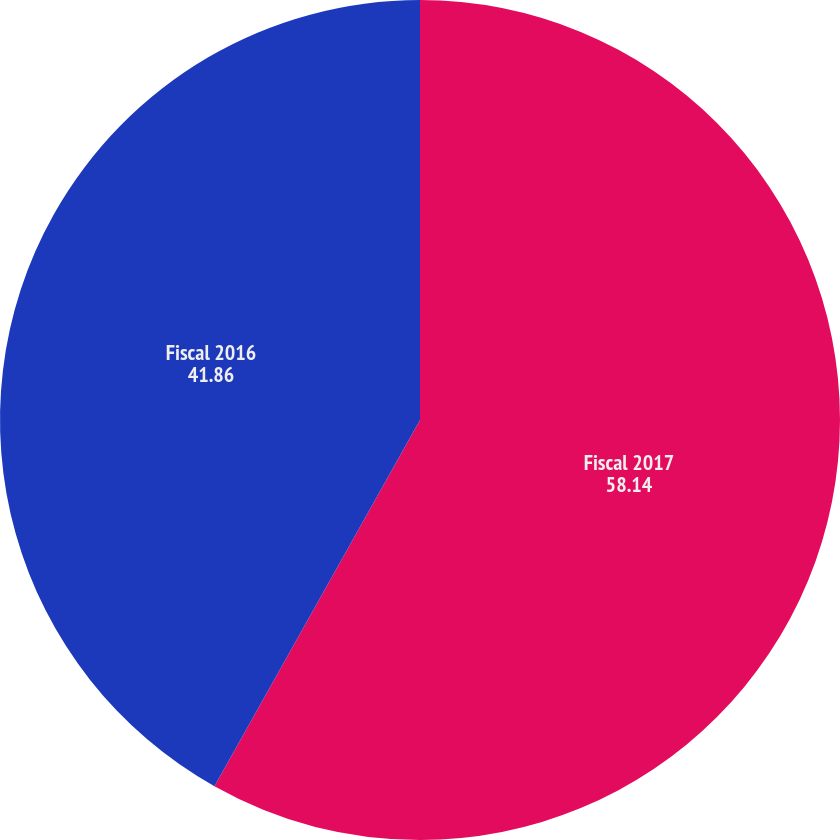Convert chart to OTSL. <chart><loc_0><loc_0><loc_500><loc_500><pie_chart><fcel>Fiscal 2017<fcel>Fiscal 2016<nl><fcel>58.14%<fcel>41.86%<nl></chart> 